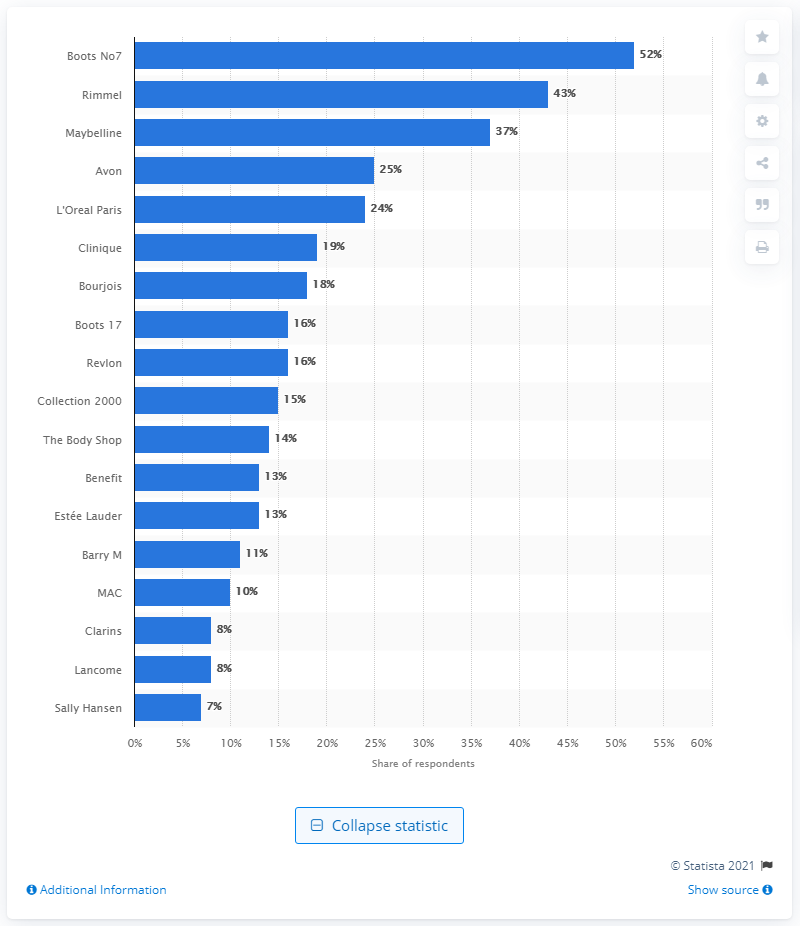Highlight a few significant elements in this photo. Boots' cosmetics brand is named No7. 